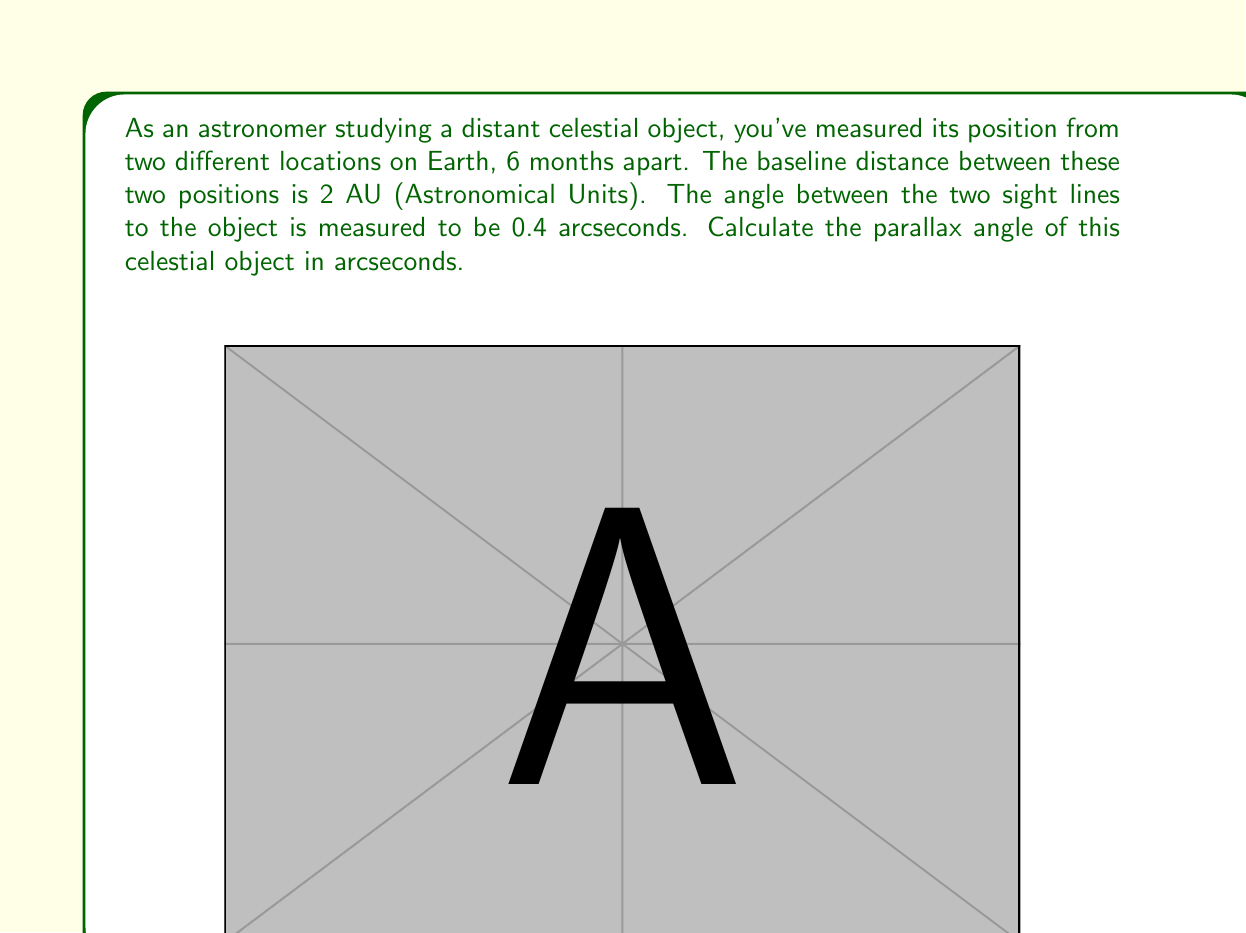Show me your answer to this math problem. To solve this problem, we need to use the concept of parallax and apply basic trigonometry. Let's break it down step-by-step:

1) The parallax angle is half of the total angle between the two sight lines. In this case, the total angle is 0.4 arcseconds, so the parallax angle $p$ is:

   $p = \frac{0.4''}{2} = 0.2''$

2) In the diagram, we have a right-angled triangle. The baseline (2 AU) forms the base of this triangle, and the parallax angle $p$ is the angle at the celestial object.

3) We can use the tangent function to relate the parallax angle to the baseline and the distance to the object:

   $\tan(p) = \frac{\text{opposite}}{\text{adjacent}} = \frac{\text{half baseline}}{\text{distance to object}}$

4) However, for very small angles (which is typically the case in astronomy), the tangent of the angle is approximately equal to the angle itself in radians. This is known as the small-angle approximation:

   $\tan(p) \approx p$ (when $p$ is in radians)

5) We need to convert our parallax angle from arcseconds to radians:

   $p \text{ (in radians)} = p \text{ (in arcseconds)} \times \frac{\pi}{180 \times 3600}$

   $p \text{ (in radians)} = 0.2 \times \frac{\pi}{180 \times 3600} \approx 9.6966 \times 10^{-7}$ radians

6) Now we can set up our equation:

   $9.6966 \times 10^{-7} = \frac{1 \text{ AU}}{\text{distance to object (in AU)}}$

7) However, we don't need to solve for the distance. The question asks for the parallax angle, which we've already calculated as 0.2 arcseconds.
Answer: The parallax angle of the celestial object is $0.2$ arcseconds. 